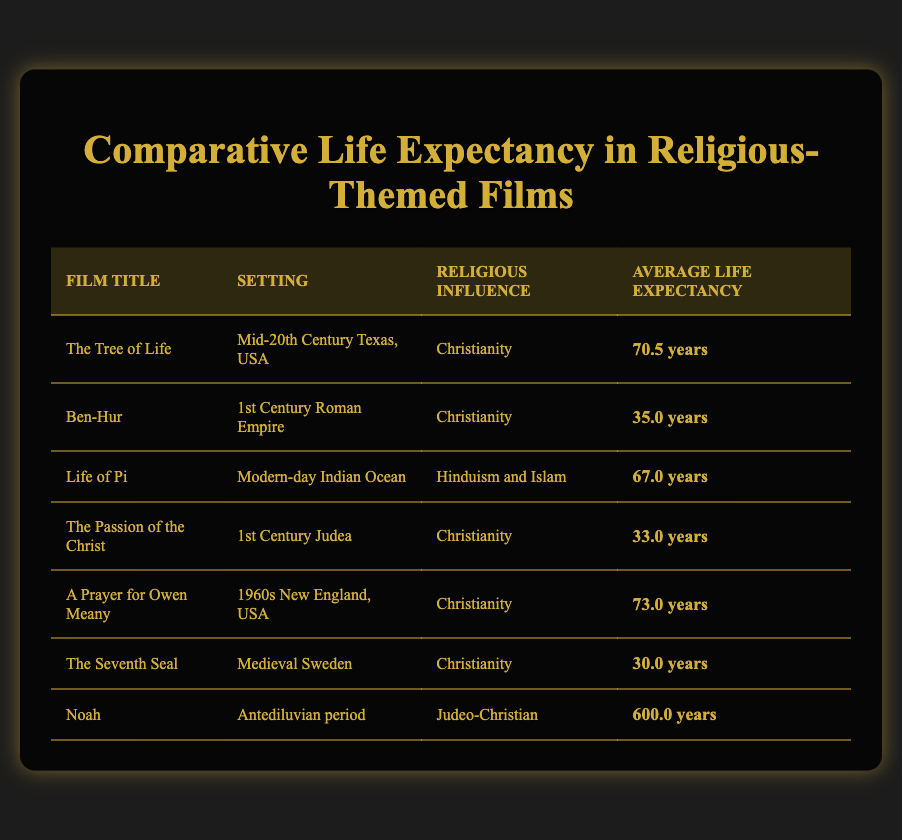What is the average life expectancy in "The Tree of Life"? The film "The Tree of Life" has an average life expectancy of 70.5 years, which is directly stated in the life expectancy data table.
Answer: 70.5 years Which film has the lowest average life expectancy? The film with the lowest average life expectancy is "The Seventh Seal," which has an average life expectancy of 30.0 years, as shown in the table.
Answer: The Seventh Seal What is the difference in life expectancy between "Ben-Hur" and "The Passion of the Christ"? "Ben-Hur" has an average life expectancy of 35.0 years, and "The Passion of the Christ" has an average life expectancy of 33.0 years. The difference is calculated as 35.0 - 33.0 = 2.0 years.
Answer: 2.0 years Is the average life expectancy in films influenced by Christianity generally higher than those influenced by Hinduism and Islam? Films influenced by Christianity have multiple entries (The Tree of Life, Ben-Hur, The Passion of the Christ, A Prayer for Owen Meany, The Seventh Seal) with average life expectancies of 70.5, 35.0, 33.0, 73.0, and 30.0 years. The average for these films is (70.5 + 35.0 + 33.0 + 73.0 + 30.0) / 5 = 41.52 years. "Life of Pi," influenced by Hinduism and Islam, has an average of 67.0 years, which is higher than 41.52 years. Thus, the statement is false.
Answer: False What is the combined average life expectancy of all films listed? To find the combined average, sum all life expectancies: (70.5 + 35.0 + 67.0 + 33.0 + 73.0 + 30.0 + 600.0) = 908.5 years. There are 7 films, so the average is 908.5 / 7 ≈ 129.64 years.
Answer: Approximately 129.64 years 